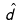<formula> <loc_0><loc_0><loc_500><loc_500>\hat { d }</formula> 